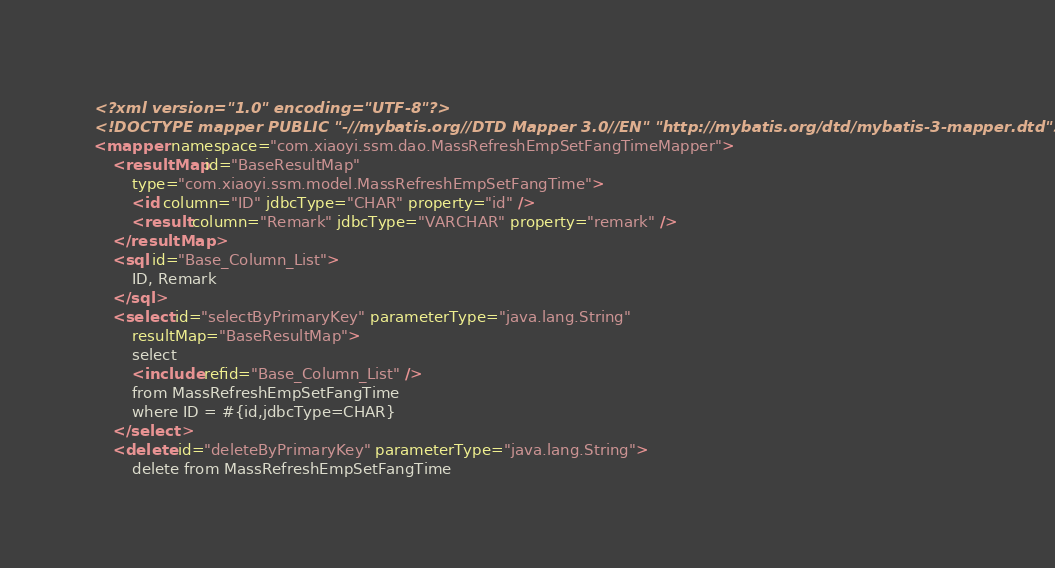<code> <loc_0><loc_0><loc_500><loc_500><_XML_><?xml version="1.0" encoding="UTF-8"?>
<!DOCTYPE mapper PUBLIC "-//mybatis.org//DTD Mapper 3.0//EN" "http://mybatis.org/dtd/mybatis-3-mapper.dtd">
<mapper namespace="com.xiaoyi.ssm.dao.MassRefreshEmpSetFangTimeMapper">
	<resultMap id="BaseResultMap"
		type="com.xiaoyi.ssm.model.MassRefreshEmpSetFangTime">
		<id column="ID" jdbcType="CHAR" property="id" />
		<result column="Remark" jdbcType="VARCHAR" property="remark" />
	</resultMap>
	<sql id="Base_Column_List">
		ID, Remark
	</sql>
	<select id="selectByPrimaryKey" parameterType="java.lang.String"
		resultMap="BaseResultMap">
		select
		<include refid="Base_Column_List" />
		from MassRefreshEmpSetFangTime
		where ID = #{id,jdbcType=CHAR}
	</select>
	<delete id="deleteByPrimaryKey" parameterType="java.lang.String">
		delete from MassRefreshEmpSetFangTime</code> 